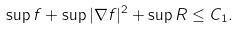<formula> <loc_0><loc_0><loc_500><loc_500>\sup f + \sup | \nabla f | ^ { 2 } + \sup R \leq C _ { 1 } .</formula> 